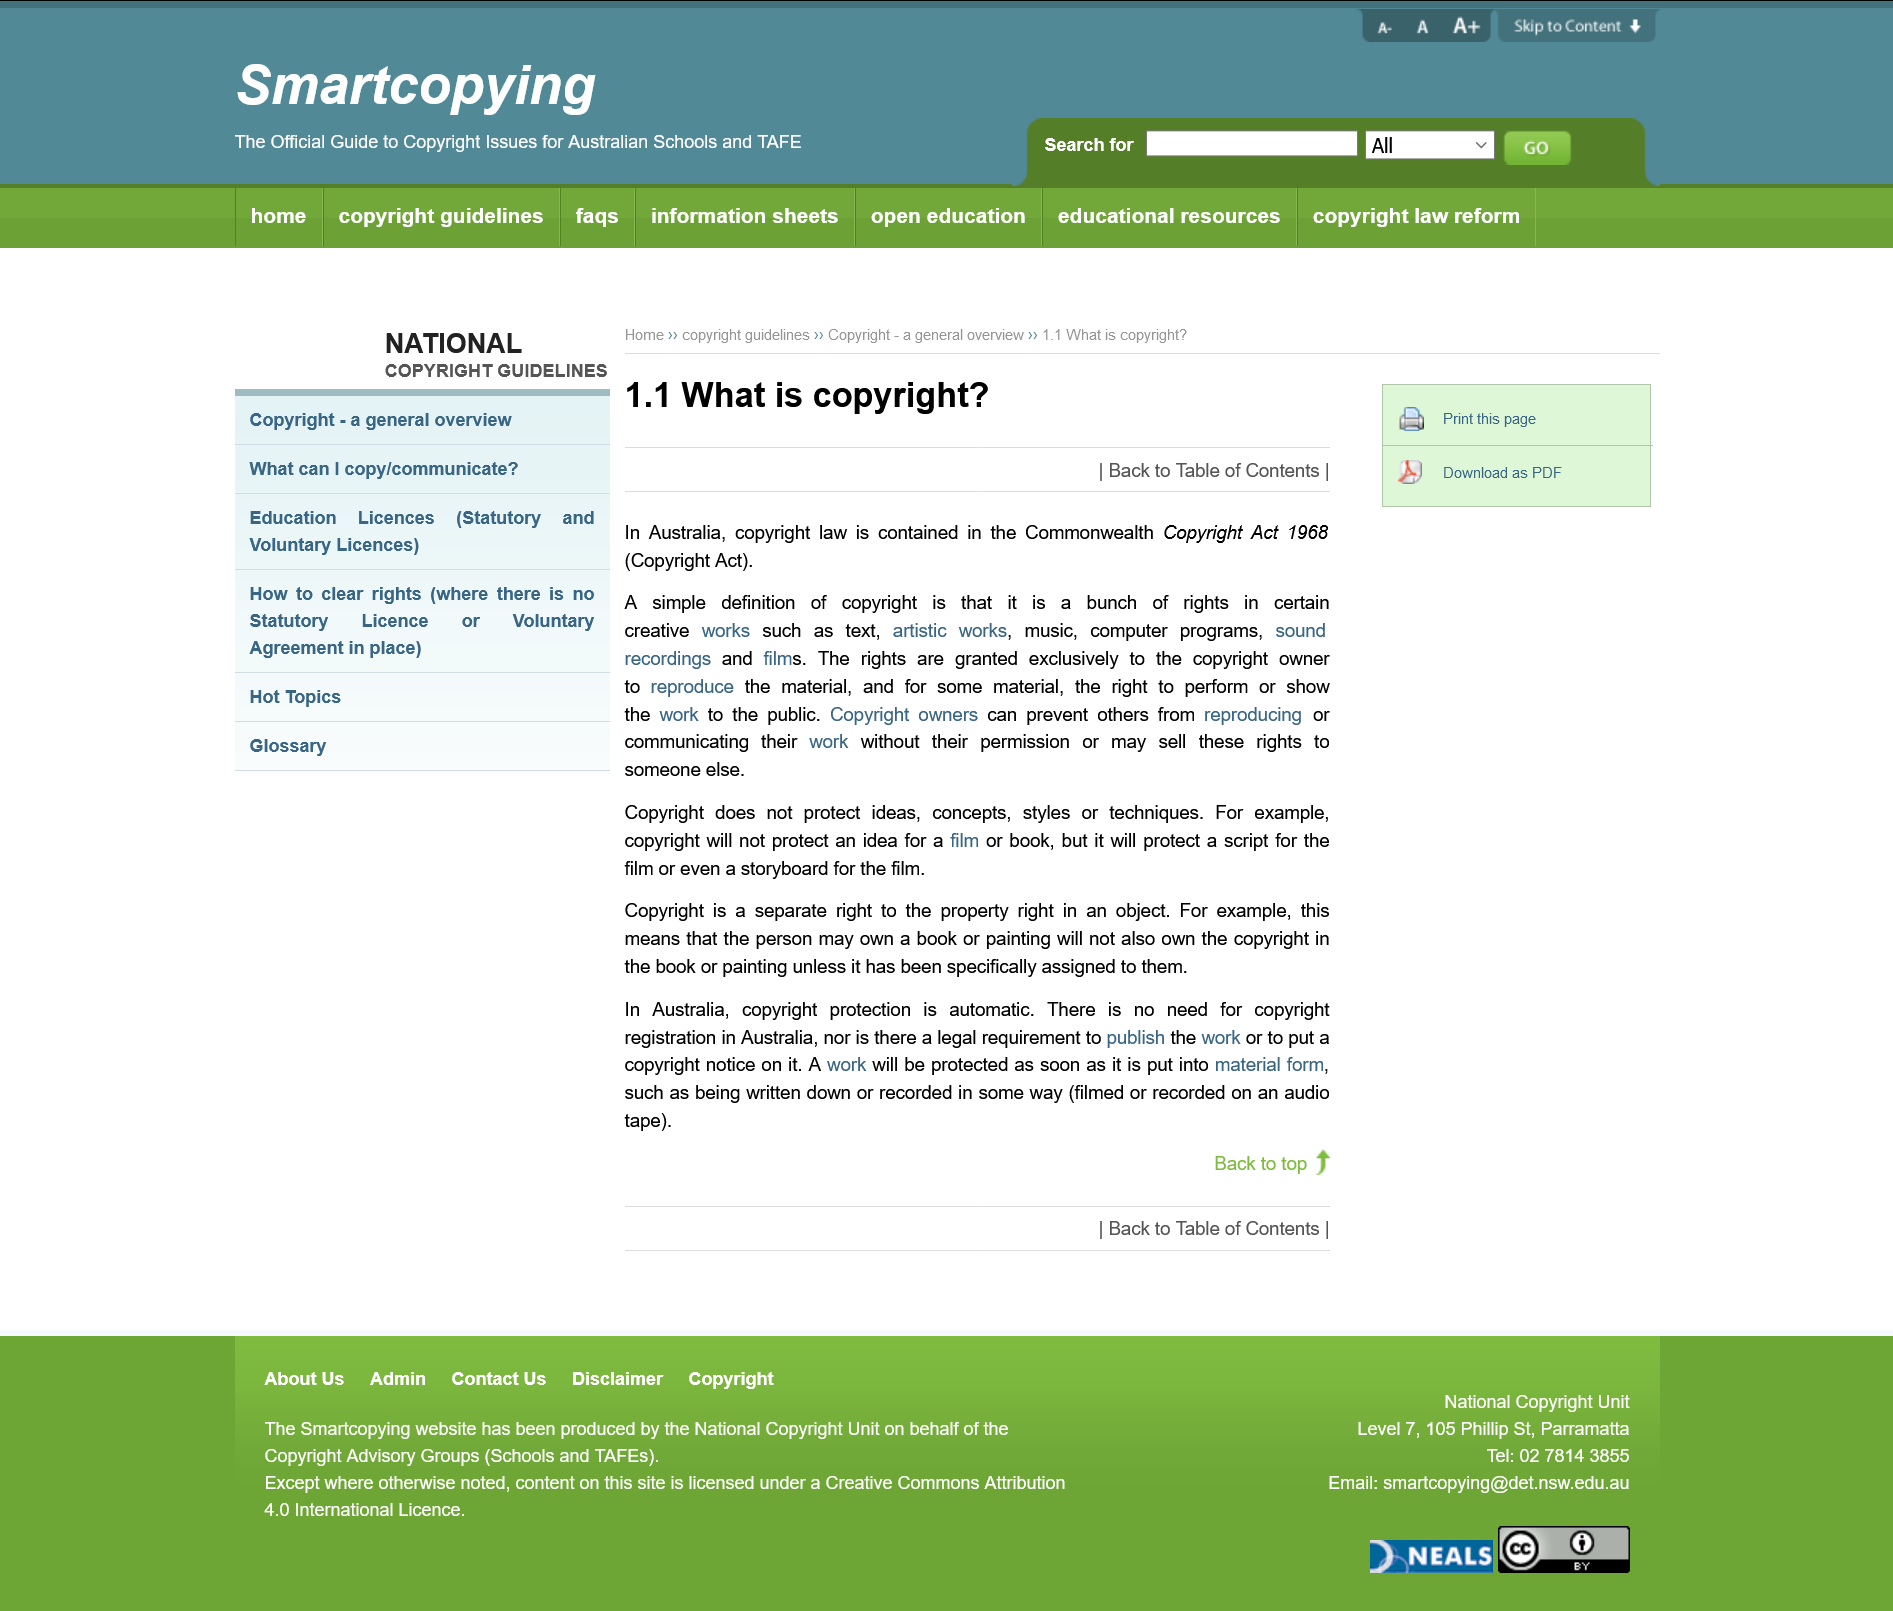List a handful of essential elements in this visual. The rights granted to the copyright owner are exclusive and are not available to any other person or entity. Copyright will protect a script or film, including storyboards, from unauthorized use or reproduction. Copyright will not protect the idea for a film or book, it will only protect the specific expression of that idea. 